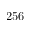Convert formula to latex. <formula><loc_0><loc_0><loc_500><loc_500>2 5 6</formula> 